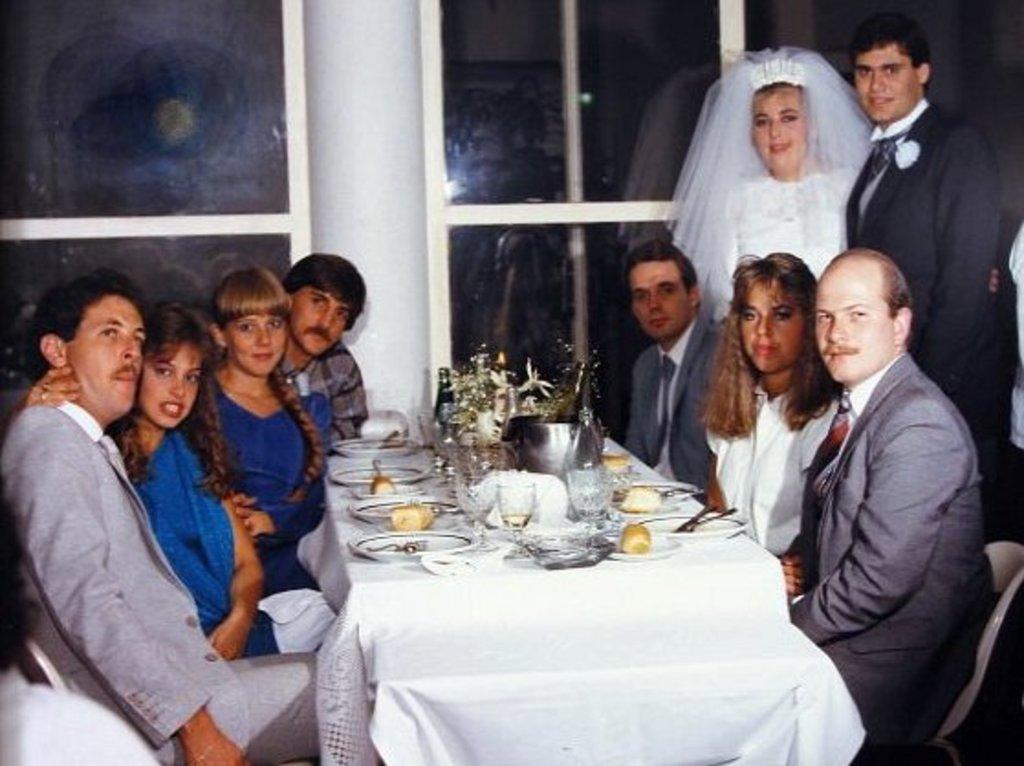Could you give a brief overview of what you see in this image? Here we can see a group of people sitting on chairs with food present in front of them on the table present in front of them and beside them we can see the bride and groom and this we can say by seeing their attire 